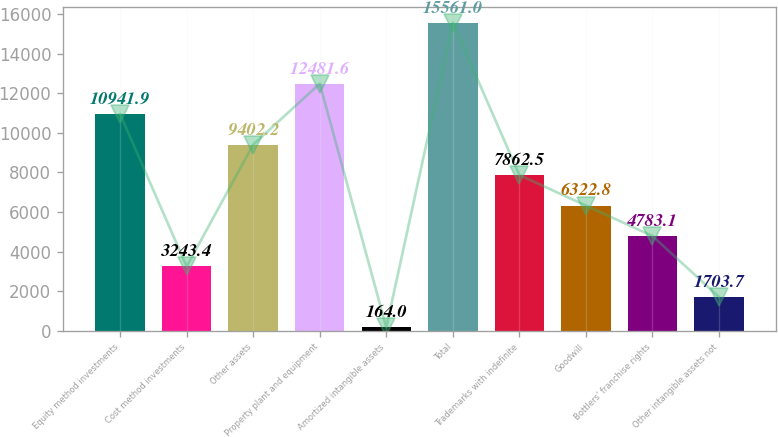Convert chart. <chart><loc_0><loc_0><loc_500><loc_500><bar_chart><fcel>Equity method investments<fcel>Cost method investments<fcel>Other assets<fcel>Property plant and equipment<fcel>Amortized intangible assets<fcel>Total<fcel>Trademarks with indefinite<fcel>Goodwill<fcel>Bottlers' franchise rights<fcel>Other intangible assets not<nl><fcel>10941.9<fcel>3243.4<fcel>9402.2<fcel>12481.6<fcel>164<fcel>15561<fcel>7862.5<fcel>6322.8<fcel>4783.1<fcel>1703.7<nl></chart> 